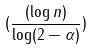Convert formula to latex. <formula><loc_0><loc_0><loc_500><loc_500>( \frac { ( \log n ) } { \log ( 2 - \alpha ) } )</formula> 